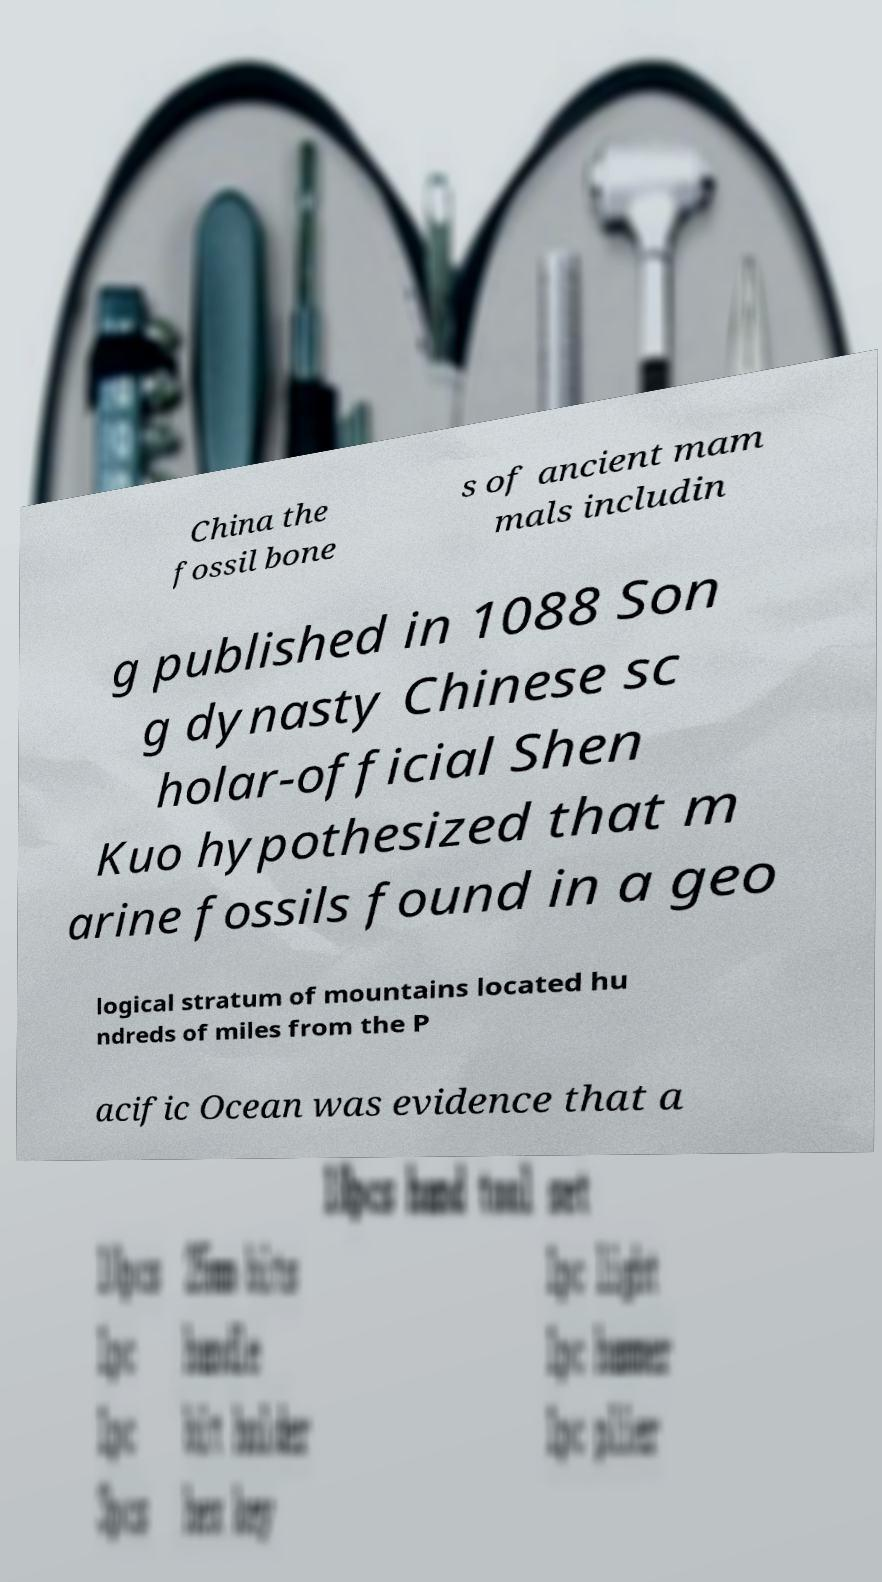Could you extract and type out the text from this image? China the fossil bone s of ancient mam mals includin g published in 1088 Son g dynasty Chinese sc holar-official Shen Kuo hypothesized that m arine fossils found in a geo logical stratum of mountains located hu ndreds of miles from the P acific Ocean was evidence that a 